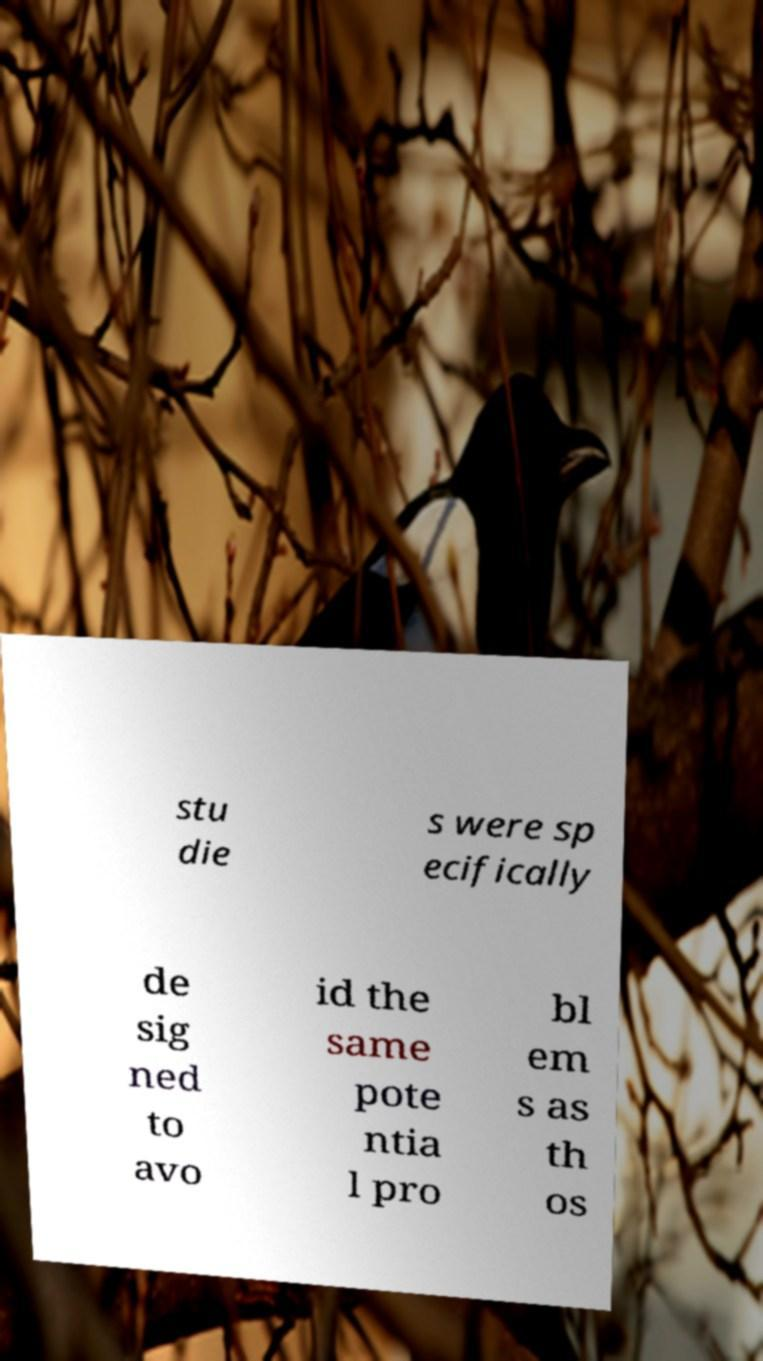Could you extract and type out the text from this image? stu die s were sp ecifically de sig ned to avo id the same pote ntia l pro bl em s as th os 